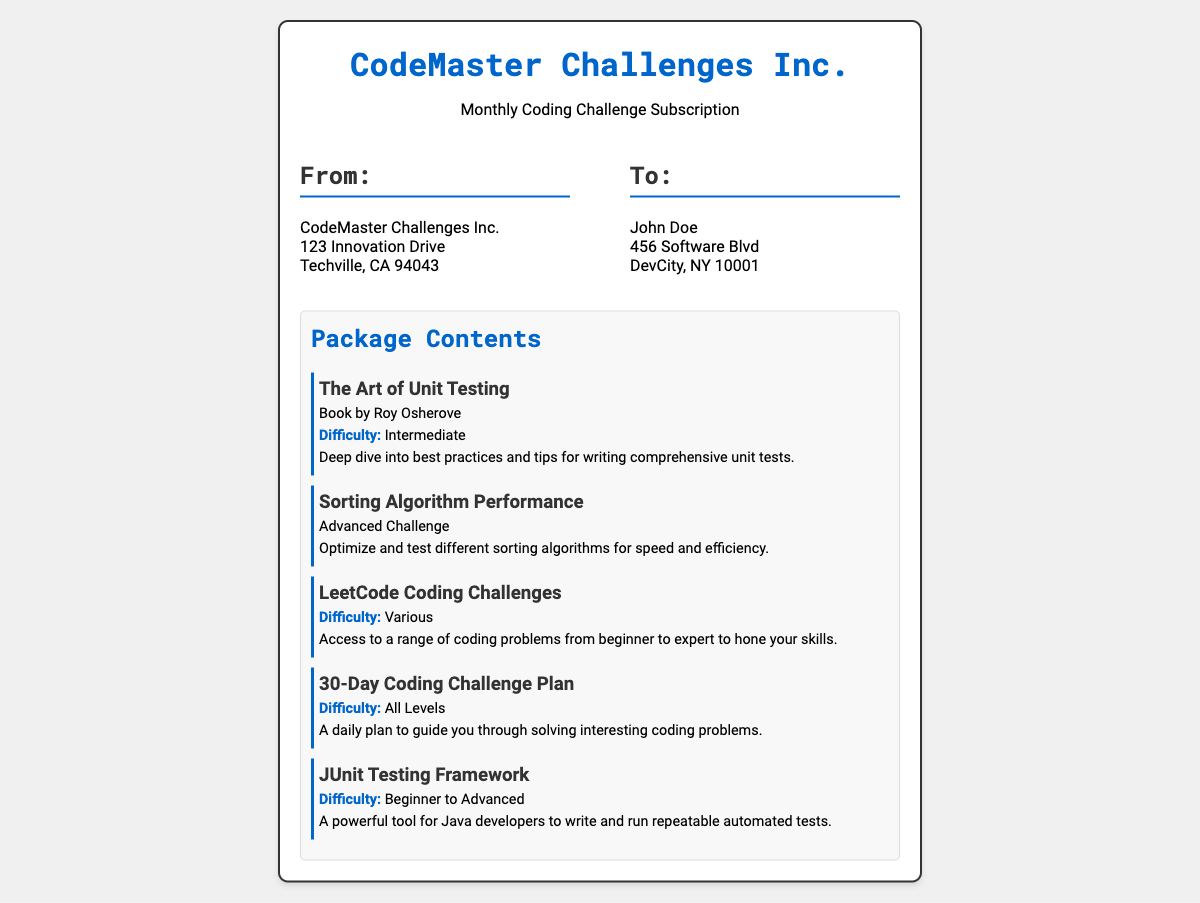What is the name of the company? The company name is stated at the top of the shipping label in bold.
Answer: CodeMaster Challenges Inc Who is the recipient? The recipient's name is listed in the "To:" section of the addresses.
Answer: John Doe What is the difficulty level of "The Art of Unit Testing"? The difficulty level is mentioned under the description for this item in the package contents.
Answer: Intermediate How many items are listed in the package contents? The total number of items can be counted from the content item sections in the document.
Answer: Five What is the address of the sender? The sender's address is provided in the "From:" section of the addresses.
Answer: CodeMaster Challenges Inc., 123 Innovation Drive, Techville, CA 94043 What kind of challenges does the "30-Day Coding Challenge Plan" include? The difficulty level for this item is highlighted in the description.
Answer: All Levels What is the title of the first content item? The first item's title is the initial content listed under the package contents.
Answer: The Art of Unit Testing Which item is an advanced challenge? The item that specifies it is an "Advanced Challenge" is described in the package contents.
Answer: Sorting Algorithm Performance What is the main focus of the "JUnit Testing Framework"? The focus of this item is indicated in its description.
Answer: Automated tests 